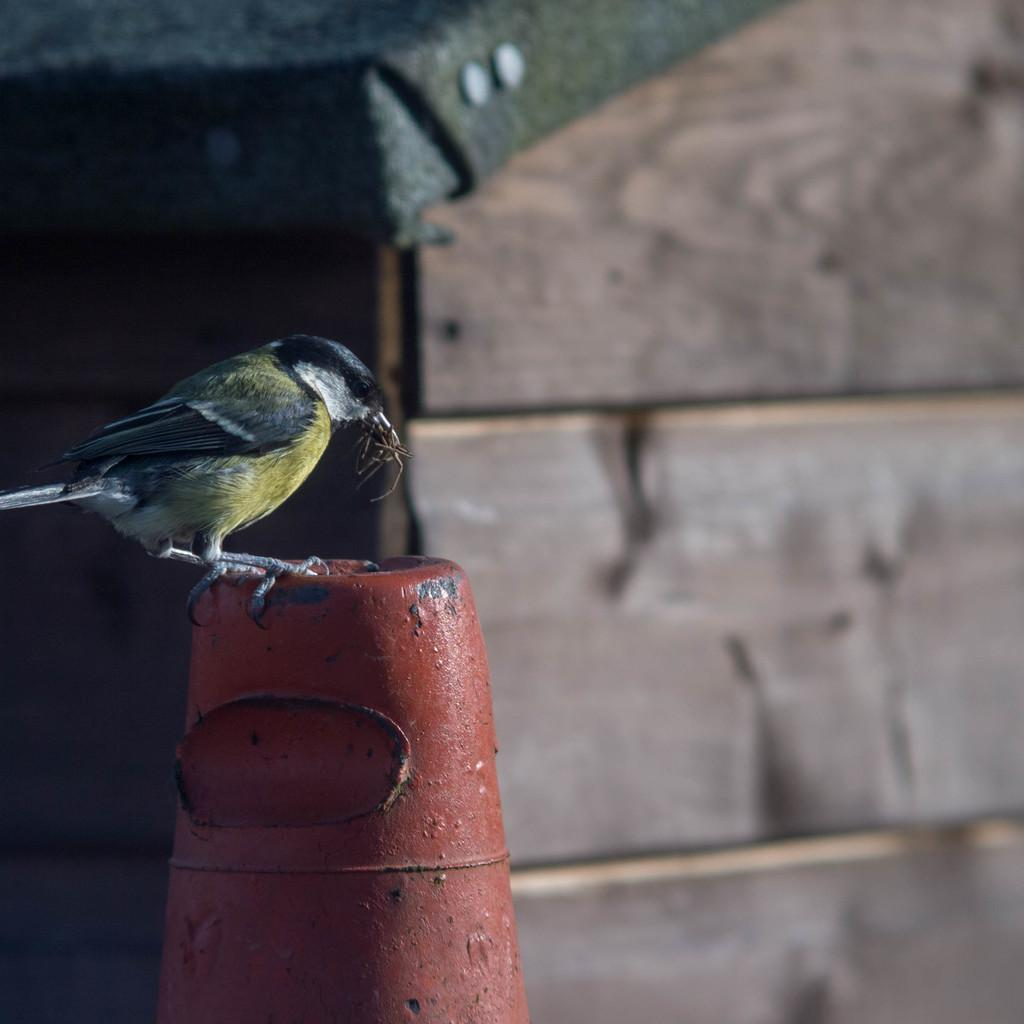What type of animal is present in the image? There is a bird in the image. Can you describe the color of the bird? The bird is in black and yellow color. What can be seen in the background of the image? There is a wooden box in the background of the image. What type of jeans is the bird wearing in the image? Birds do not wear jeans, as they are animals and not human. The bird in the image is not wearing any clothing. 